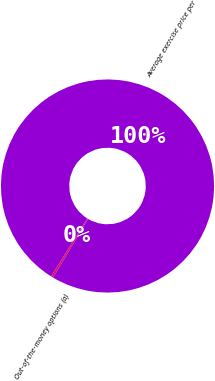Convert chart. <chart><loc_0><loc_0><loc_500><loc_500><pie_chart><fcel>Out-of-the-money options (a)<fcel>Average exercise price per<nl><fcel>0.36%<fcel>99.64%<nl></chart> 